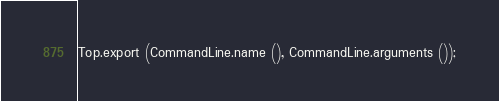Convert code to text. <code><loc_0><loc_0><loc_500><loc_500><_SML_>Top.export (CommandLine.name (), CommandLine.arguments ());
</code> 